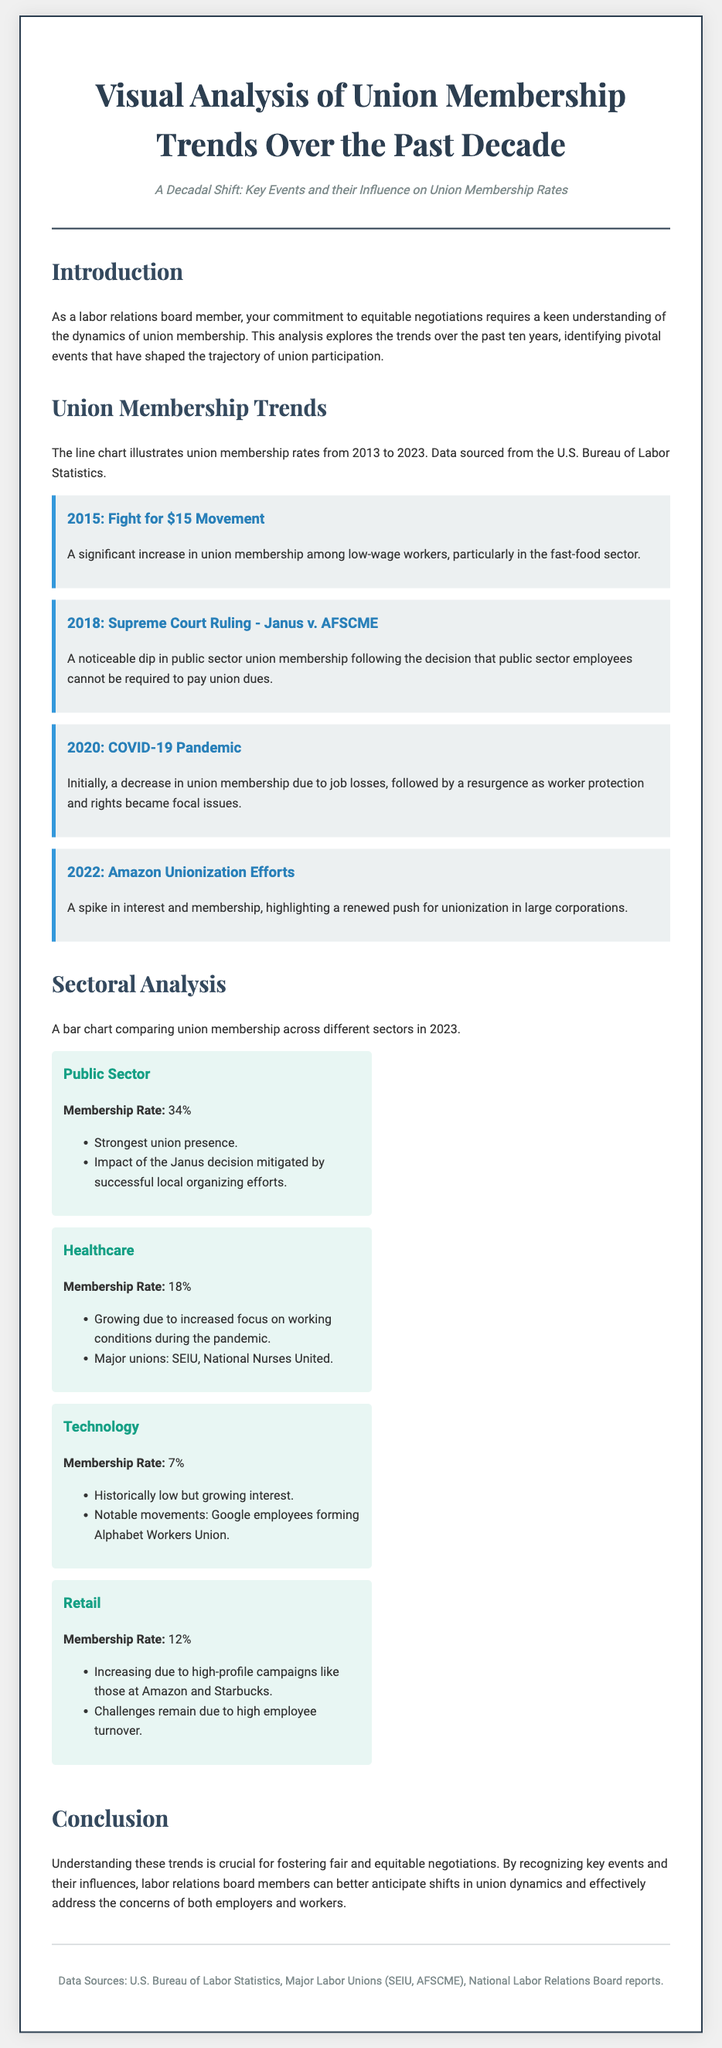What was the membership rate in the public sector in 2023? The document states the membership rate in the public sector is 34%.
Answer: 34% Which event in 2015 increased union membership among low-wage workers? The 2015 event that increased membership is the Fight for $15 Movement.
Answer: Fight for $15 Movement What percentage of membership is reported in the technology sector? The technology sector has a membership rate of 7% as mentioned in the document.
Answer: 7% What Supreme Court ruling in 2018 influenced public sector union membership? The ruling was Janus v. AFSCME, which affected public sector union membership rates.
Answer: Janus v. AFSCME Which major unions are mentioned in the healthcare sector? The document mentions SEIU and National Nurses United as major unions in healthcare.
Answer: SEIU, National Nurses United What year saw a resurgence in union membership due to worker protection issues? The year that saw a resurgence in membership post the initial decline was 2020.
Answer: 2020 What is the key theme of the introduction section in the document? The introduction emphasizes the importance of understanding union membership dynamics for equitable negotiations.
Answer: Equitable negotiations How did the COVID-19 pandemic initially affect union membership? The pandemic initially led to a decrease in union membership due to job losses.
Answer: Decrease What is the document type of this content? The content is a Playbill that visually analyzes union membership trends over a decade.
Answer: Playbill 